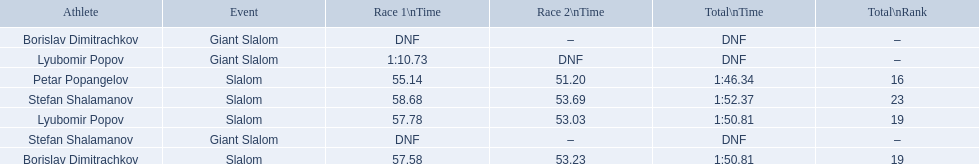Which event is the giant slalom? Giant Slalom, Giant Slalom, Giant Slalom. Which one is lyubomir popov? Lyubomir Popov. What is race 1 tim? 1:10.73. 